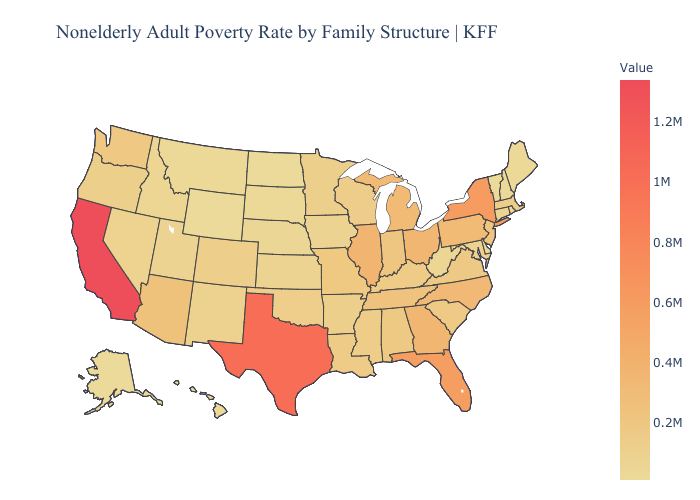Does Texas have the highest value in the South?
Write a very short answer. Yes. Does Hawaii have the lowest value in the USA?
Quick response, please. No. Among the states that border Maine , which have the lowest value?
Short answer required. New Hampshire. Which states have the lowest value in the USA?
Keep it brief. Wyoming. Does California have the highest value in the USA?
Write a very short answer. Yes. Does the map have missing data?
Quick response, please. No. 